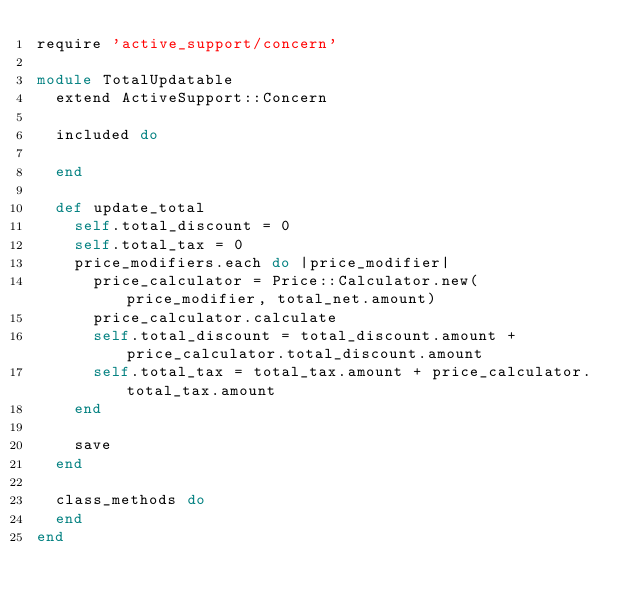Convert code to text. <code><loc_0><loc_0><loc_500><loc_500><_Ruby_>require 'active_support/concern'

module TotalUpdatable
  extend ActiveSupport::Concern

  included do

  end

  def update_total
    self.total_discount = 0
    self.total_tax = 0
    price_modifiers.each do |price_modifier|
      price_calculator = Price::Calculator.new(price_modifier, total_net.amount)
      price_calculator.calculate
      self.total_discount = total_discount.amount + price_calculator.total_discount.amount
      self.total_tax = total_tax.amount + price_calculator.total_tax.amount
    end

    save
  end

  class_methods do
  end
end</code> 